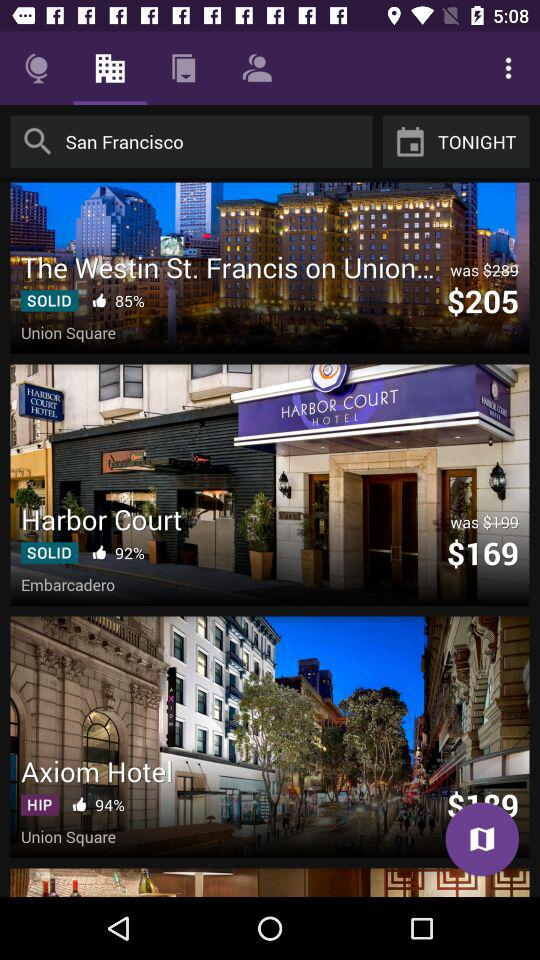What is the % of likes for "Harbor Court"? The percentage of likes is 92. 